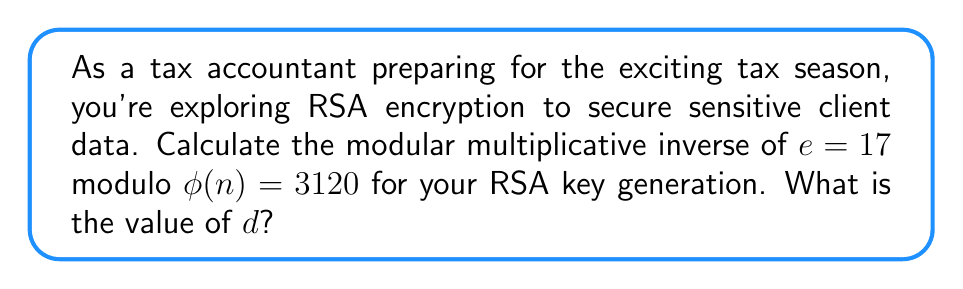What is the answer to this math problem? To find the modular multiplicative inverse of $e$ modulo $\phi(n)$, we need to find a value $d$ such that:

$$(e \cdot d) \equiv 1 \pmod{\phi(n)}$$

We can use the extended Euclidean algorithm to find $d$:

1) Start with the equation: $3120 = 183 \cdot 17 + 9$
2) Rearrange: $9 = 3120 - 183 \cdot 17$
3) Continue:
   $17 = 1 \cdot 9 + 8$
   $9 = 1 \cdot 8 + 1$
   $8 = 8 \cdot 1 + 0$

4) Work backwards to express 1 as a linear combination of 3120 and 17:
   $1 = 9 - 1 \cdot 8$
   $1 = 9 - 1 \cdot (17 - 1 \cdot 9) = 2 \cdot 9 - 1 \cdot 17$
   $1 = 2 \cdot (3120 - 183 \cdot 17) - 1 \cdot 17$
   $1 = 2 \cdot 3120 - 367 \cdot 17$

5) Therefore, $-367 \cdot 17 \equiv 1 \pmod{3120}$

6) To get a positive value for $d$, add $\phi(n)$ until it's positive:
   $d = -367 + 3120 = 2753$

Verify: $(17 \cdot 2753) \bmod 3120 = 46801 \bmod 3120 = 1$
Answer: $d = 2753$ 